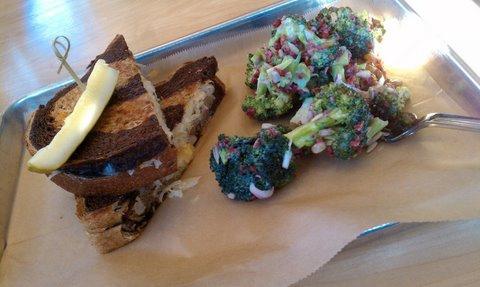What type of bread is used in the sandwich?
Quick response, please. Rye. Is this food healthy?
Answer briefly. Yes. What vegetable is shown?
Quick response, please. Broccoli. 